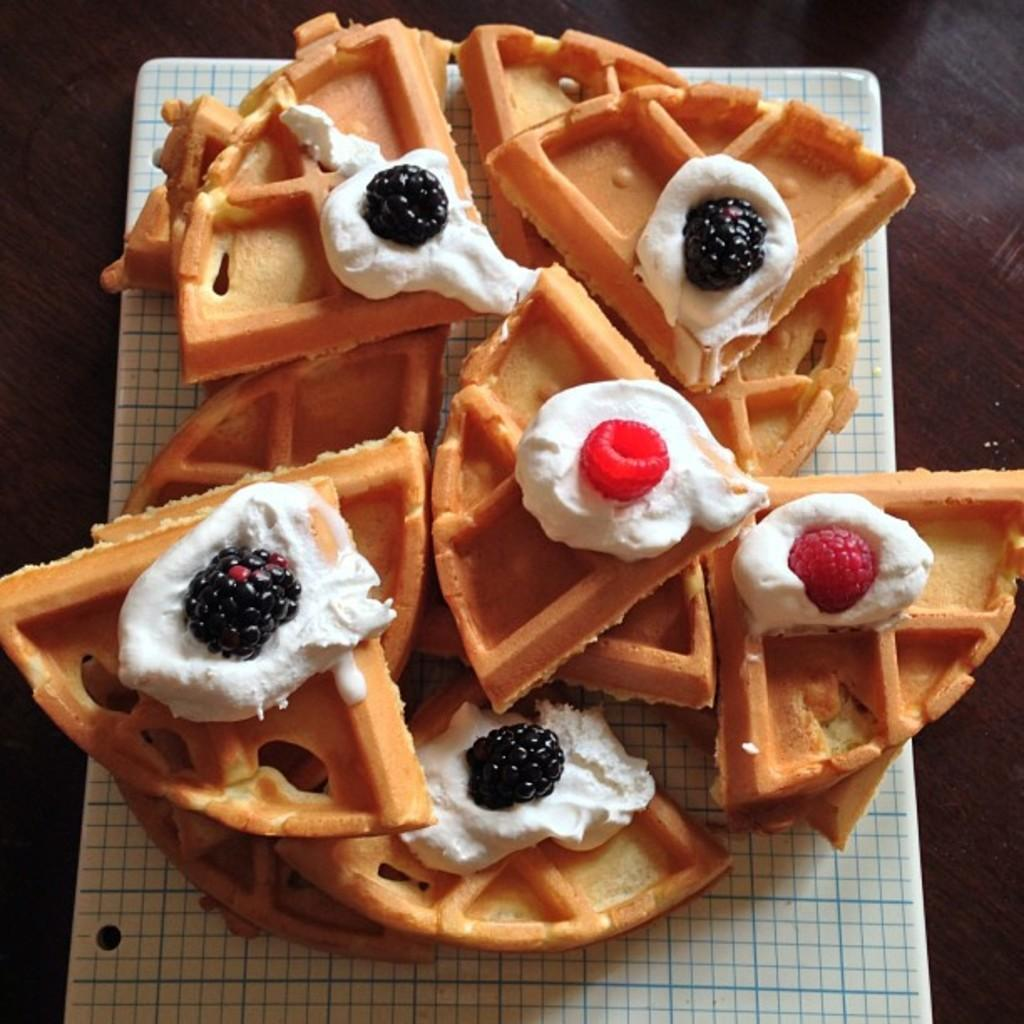What type of food is visible in the image? There are waffles in the image. What is on top of the waffles? The waffles have cream and berry topping on them. What type of cup can be seen holding the beetle in the image? There is no cup or beetle present in the image; it only features waffles with cream and berry topping. 